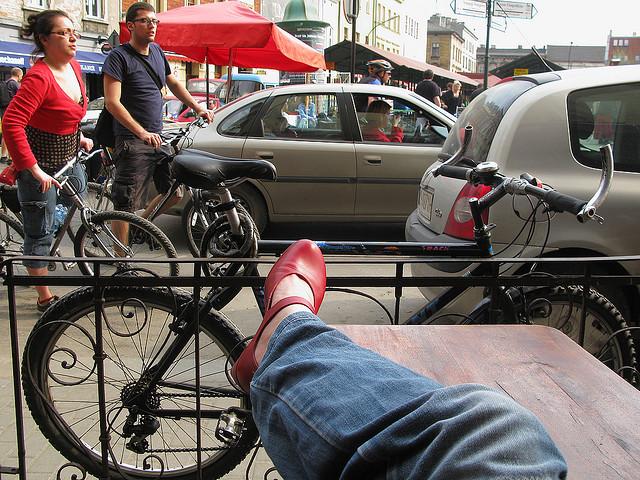What color shirt is the man wearing?
Keep it brief. Blue. Is it daytime?
Write a very short answer. Yes. Is the riderless bike chained to the grill?
Concise answer only. Yes. 